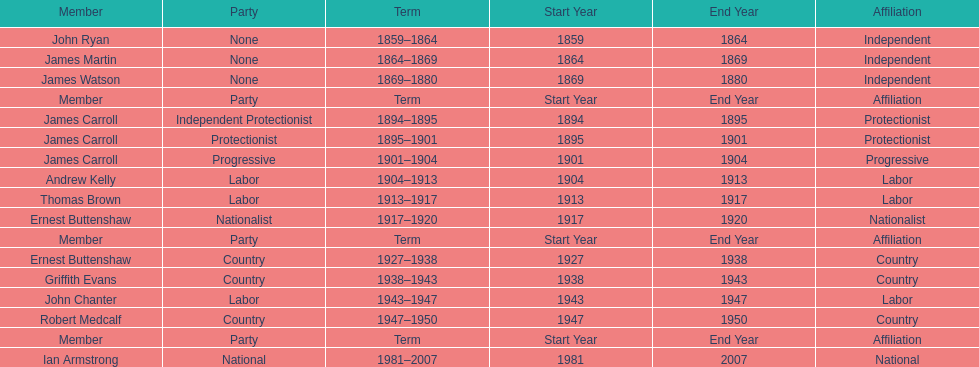Of the members of the third incarnation of the lachlan, who served the longest? Ernest Buttenshaw. 